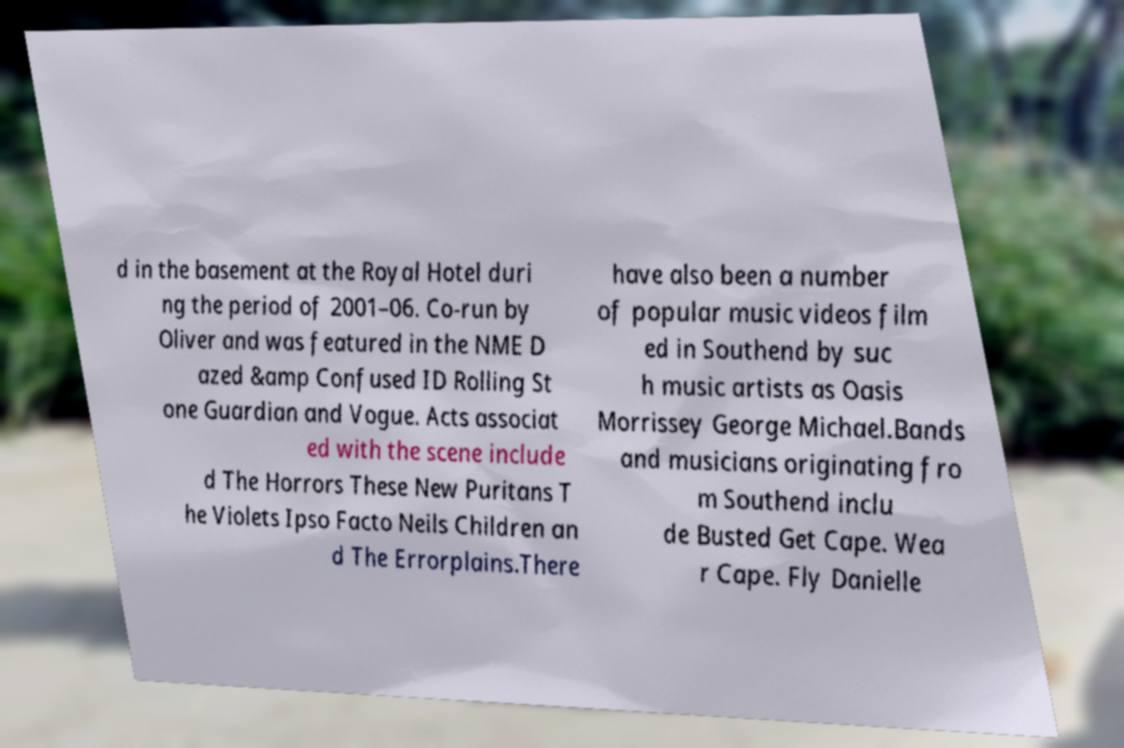Please read and relay the text visible in this image. What does it say? d in the basement at the Royal Hotel duri ng the period of 2001–06. Co-run by Oliver and was featured in the NME D azed &amp Confused ID Rolling St one Guardian and Vogue. Acts associat ed with the scene include d The Horrors These New Puritans T he Violets Ipso Facto Neils Children an d The Errorplains.There have also been a number of popular music videos film ed in Southend by suc h music artists as Oasis Morrissey George Michael.Bands and musicians originating fro m Southend inclu de Busted Get Cape. Wea r Cape. Fly Danielle 